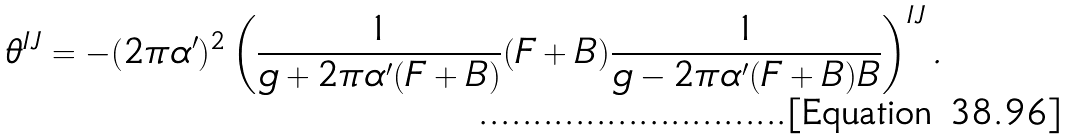Convert formula to latex. <formula><loc_0><loc_0><loc_500><loc_500>\theta ^ { I J } = - ( 2 \pi \alpha ^ { \prime } ) ^ { 2 } \left ( \frac { 1 } { g + 2 \pi \alpha ^ { \prime } ( F + B ) } ( F + B ) \frac { 1 } { g - 2 \pi \alpha ^ { \prime } ( F + B ) B } \right ) ^ { I J } .</formula> 